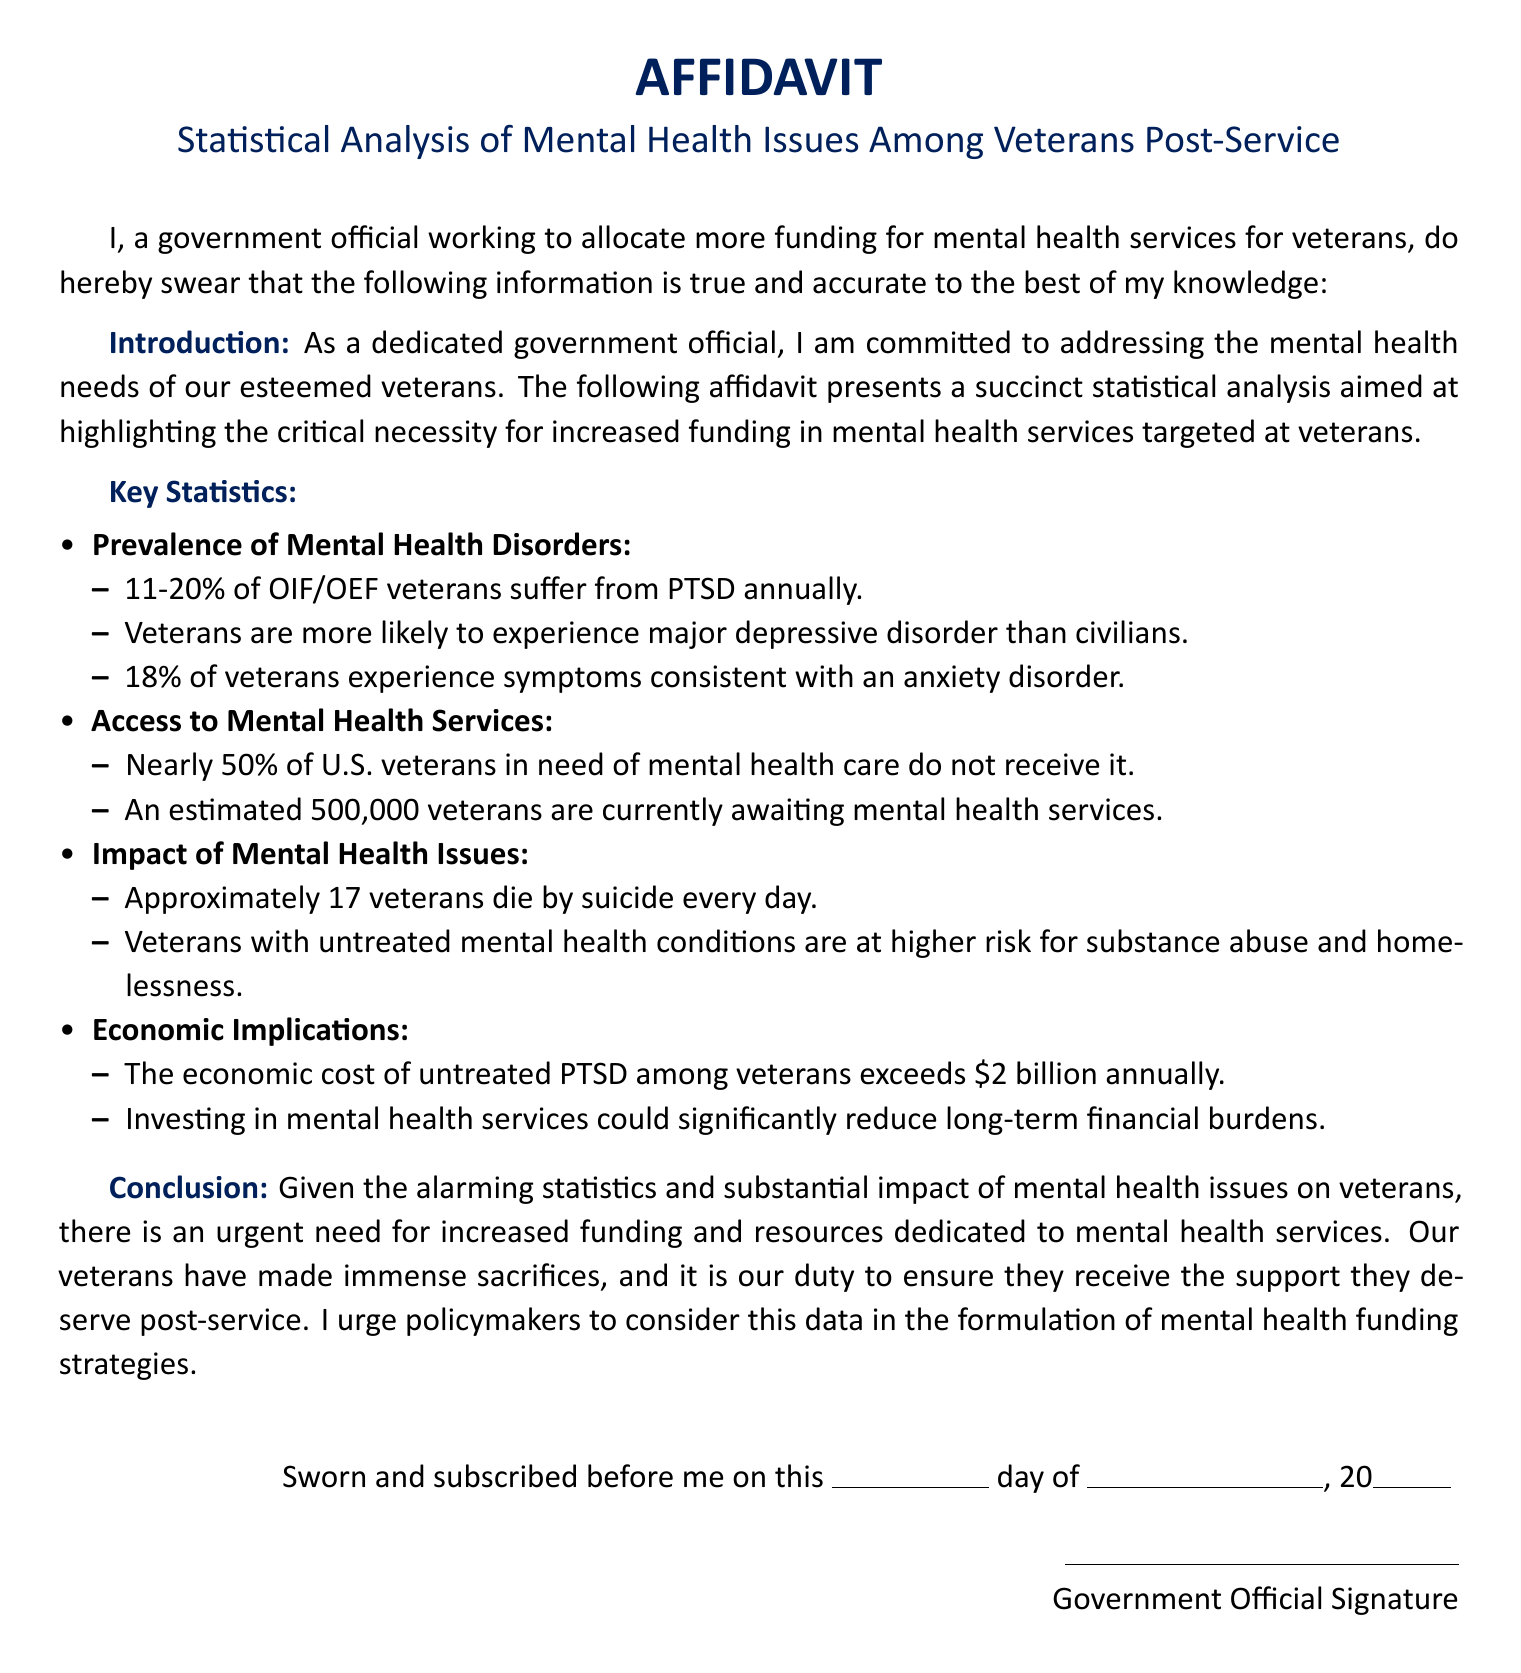What percentage of OIF/OEF veterans suffer from PTSD? The document states that 11-20% of OIF/OEF veterans suffer from PTSD annually.
Answer: 11-20% How many veterans are currently awaiting mental health services? According to the document, an estimated 500,000 veterans are currently awaiting mental health services.
Answer: 500,000 What is the daily suicide rate of veterans mentioned? The affidavit mentions that approximately 17 veterans die by suicide every day.
Answer: 17 What economic cost is attributed to untreated PTSD among veterans? The document indicates that the economic cost of untreated PTSD among veterans exceeds $2 billion annually.
Answer: $2 billion What is the main purpose of the affidavit? The affidavit's main purpose is to highlight the necessity for increased funding in mental health services targeted at veterans.
Answer: Increase funding What percentage of U.S. veterans in need of mental health care do not receive it? It is stated that nearly 50% of U.S. veterans in need of mental health care do not receive it.
Answer: 50% What does the conclusion urge policymakers to do? The conclusion urges policymakers to consider the data in the formulation of mental health funding strategies.
Answer: Consider the data Who signed the document? The document is signed by a government official.
Answer: Government Official 